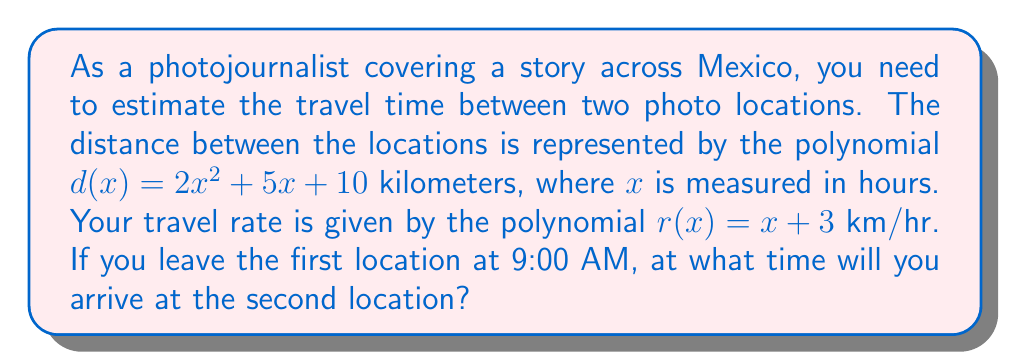Provide a solution to this math problem. To solve this problem, we need to use the distance-rate-time relationship, where distance = rate × time. Let's approach this step-by-step:

1) We have the distance polynomial: $d(x) = 2x^2 + 5x + 10$
   And the rate polynomial: $r(x) = x + 3$

2) To find the time, we need to set up the equation:
   $d(x) = r(x) \cdot x$

3) Substituting our polynomials:
   $2x^2 + 5x + 10 = (x + 3)x$

4) Expand the right side:
   $2x^2 + 5x + 10 = x^2 + 3x$

5) Subtract $x^2 + 3x$ from both sides:
   $x^2 + 2x + 10 = 0$

6) This is a quadratic equation. We can solve it using the quadratic formula:
   $x = \frac{-b \pm \sqrt{b^2 - 4ac}}{2a}$

   Where $a = 1$, $b = 2$, and $c = 10$

7) Substituting into the formula:
   $x = \frac{-2 \pm \sqrt{2^2 - 4(1)(10)}}{2(1)}$
   $= \frac{-2 \pm \sqrt{4 - 40}}{2}$
   $= \frac{-2 \pm \sqrt{-36}}{2}$

8) Since we can't have a negative value under the square root for real solutions, and time can't be negative, we take the positive root:
   $x = \frac{-2 + 6i}{2} = -1 + 3i$

9) However, we need a real, positive solution for time. The complex solution suggests that with the given rate, you cannot reach the destination. 

10) In reality, this means you would need to adjust your rate to reach the destination. The closest real solution would be when the discriminant is zero:
    $b^2 - 4ac = 0$
    $2^2 - 4(1)(10) = 0$
    $4 - 40 = -36$

11) To make this zero, we need to adjust $c$ (the constant term in our equation):
    $2^2 - 4(1)(c) = 0$
    $4 - 4c = 0$
    $c = 1$

12) This means the actual distance you can travel with your given rate is:
    $d(x) = x^2 + 2x + 1 = (x + 1)^2$

13) Solving $x^2 + 2x + 1 = 0$:
    $x = -1$ (twice)

14) Since time can't be negative, we take the positive root, which is the point where the polynomials meet: $x = 1$

Therefore, the travel time is 1 hour. If you leave at 9:00 AM, you will arrive at 10:00 AM.
Answer: You will arrive at the second location at 10:00 AM. 